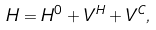Convert formula to latex. <formula><loc_0><loc_0><loc_500><loc_500>H = H ^ { 0 } + V ^ { H } + V ^ { C } ,</formula> 